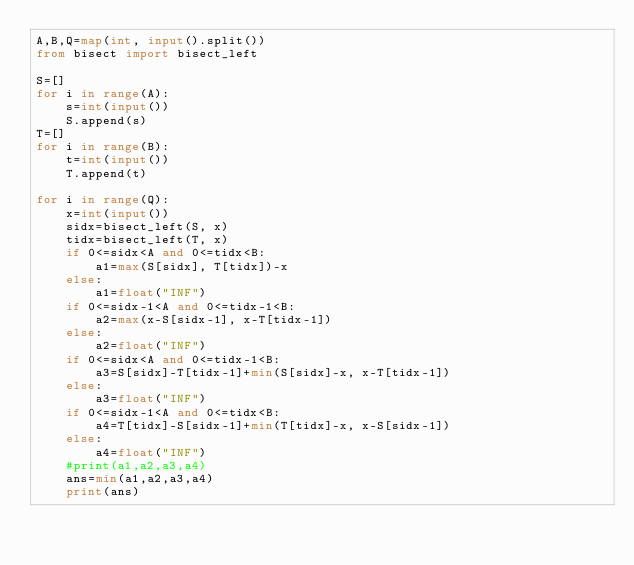<code> <loc_0><loc_0><loc_500><loc_500><_Python_>A,B,Q=map(int, input().split())
from bisect import bisect_left

S=[]
for i in range(A):
    s=int(input())
    S.append(s)
T=[]
for i in range(B):
    t=int(input())
    T.append(t)

for i in range(Q):
    x=int(input())
    sidx=bisect_left(S, x)
    tidx=bisect_left(T, x)
    if 0<=sidx<A and 0<=tidx<B:
        a1=max(S[sidx], T[tidx])-x
    else:
        a1=float("INF")
    if 0<=sidx-1<A and 0<=tidx-1<B:
        a2=max(x-S[sidx-1], x-T[tidx-1])
    else:
        a2=float("INF")
    if 0<=sidx<A and 0<=tidx-1<B:
        a3=S[sidx]-T[tidx-1]+min(S[sidx]-x, x-T[tidx-1])
    else:
        a3=float("INF")
    if 0<=sidx-1<A and 0<=tidx<B:
        a4=T[tidx]-S[sidx-1]+min(T[tidx]-x, x-S[sidx-1])
    else:
        a4=float("INF")
    #print(a1,a2,a3,a4)
    ans=min(a1,a2,a3,a4)
    print(ans)
</code> 